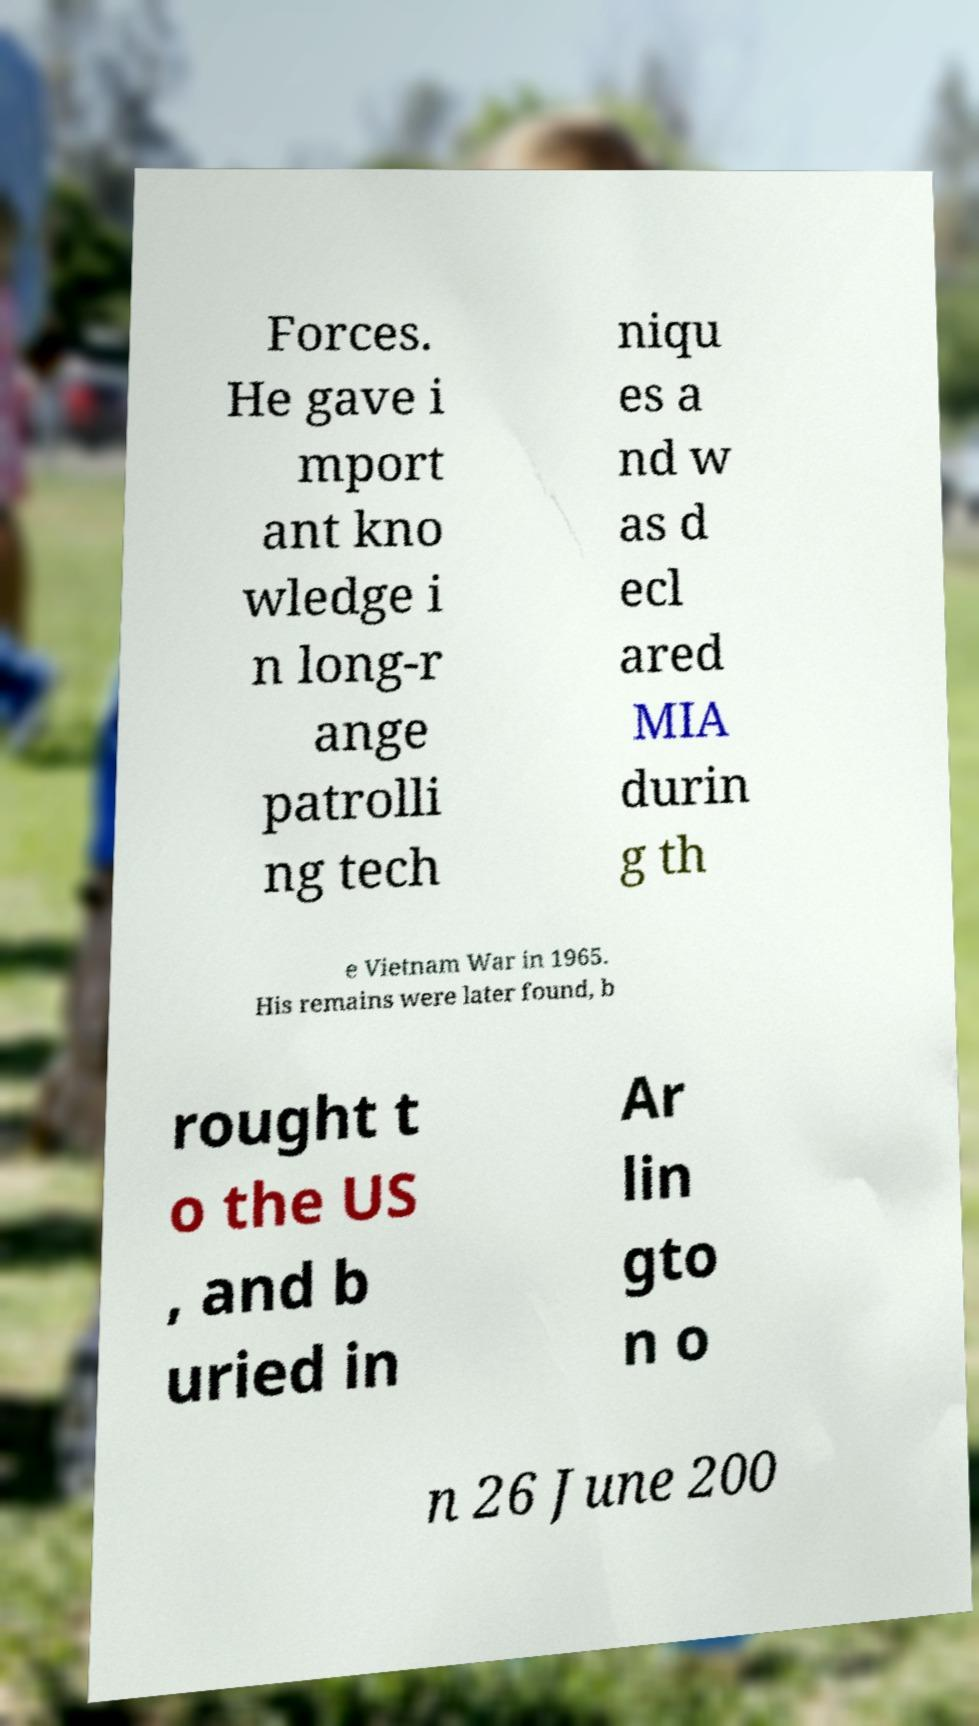Could you assist in decoding the text presented in this image and type it out clearly? Forces. He gave i mport ant kno wledge i n long-r ange patrolli ng tech niqu es a nd w as d ecl ared MIA durin g th e Vietnam War in 1965. His remains were later found, b rought t o the US , and b uried in Ar lin gto n o n 26 June 200 